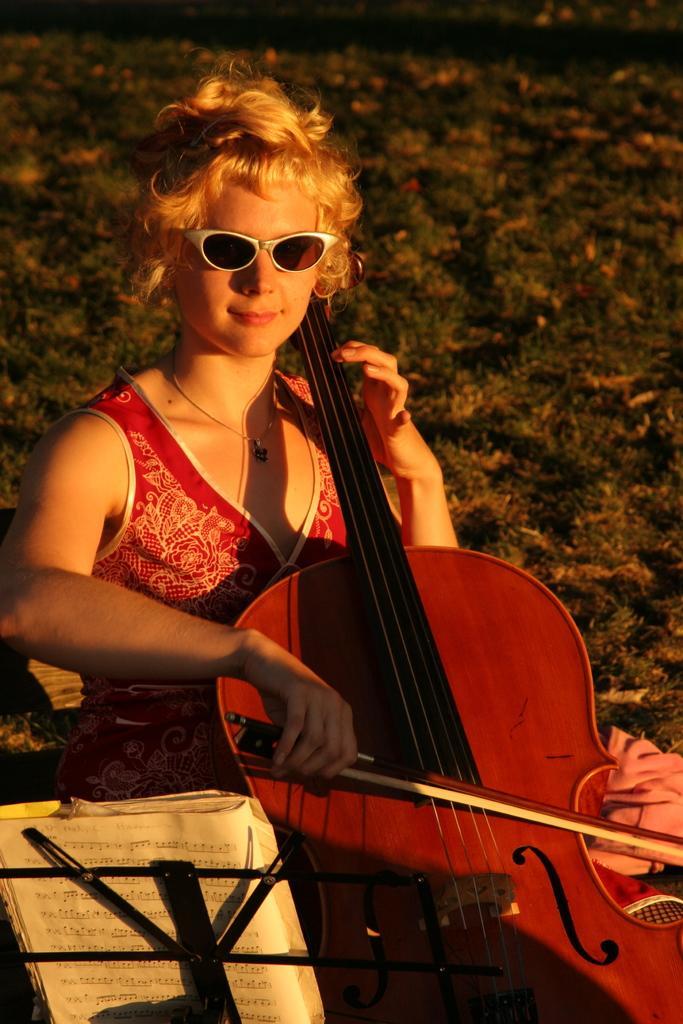How would you summarize this image in a sentence or two? Girl in this image is sitting and playing violin is wearing a spects. beside to her there is a book and the stand. Background of the image is a grassy land. 